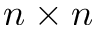Convert formula to latex. <formula><loc_0><loc_0><loc_500><loc_500>n \times n</formula> 